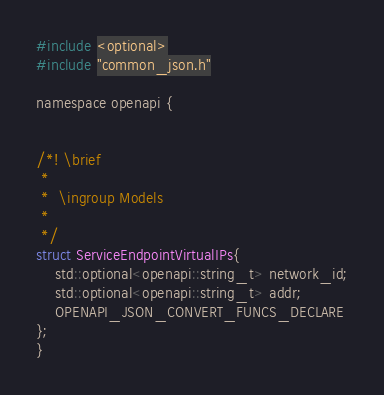Convert code to text. <code><loc_0><loc_0><loc_500><loc_500><_C_>

#include <optional>
#include "common_json.h"

namespace openapi {


/*! \brief 
 *
 *  \ingroup Models
 *
 */
struct ServiceEndpointVirtualIPs{
    std::optional<openapi::string_t> network_id;
    std::optional<openapi::string_t> addr;
    OPENAPI_JSON_CONVERT_FUNCS_DECLARE
};
}</code> 